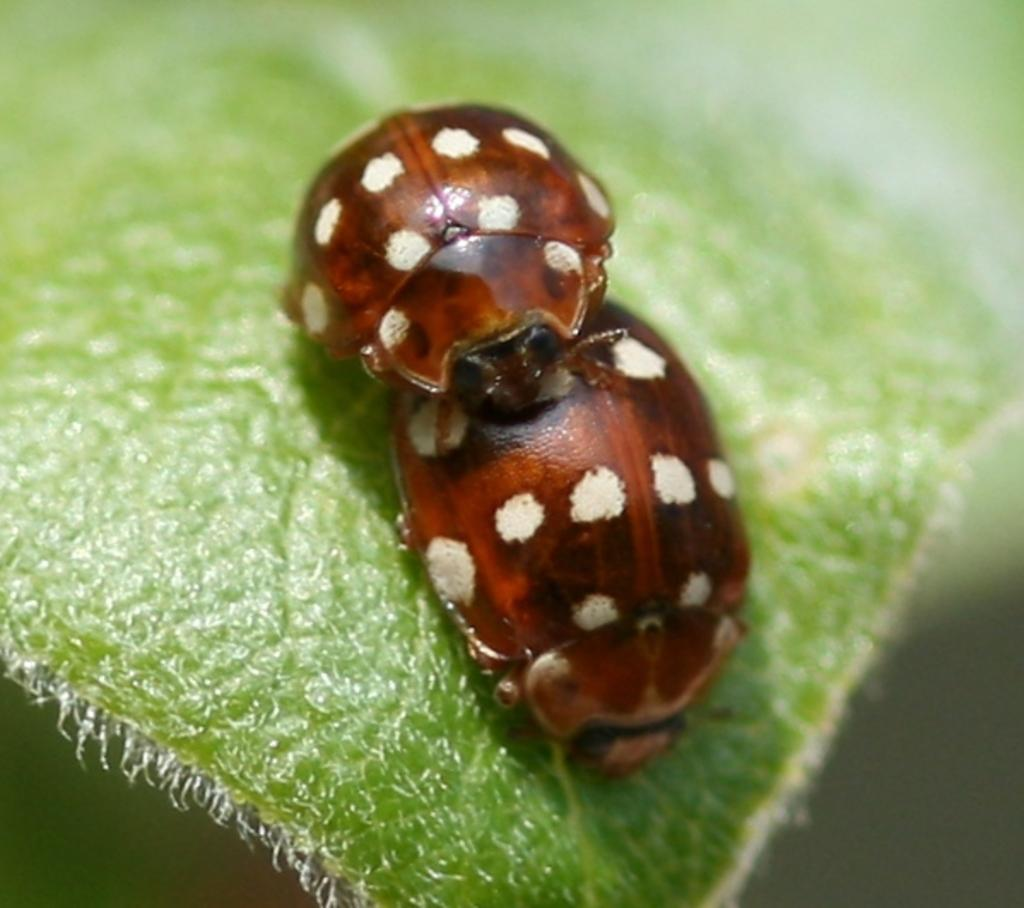What type of creatures are present in the image? There are bugs in the image. Where are the bugs located? The bugs are on a leaf. What type of afterthought is being expressed by the bugs in the image? There is no indication of an afterthought being expressed by the bugs in the image, as bugs do not have the ability to express thoughts. 